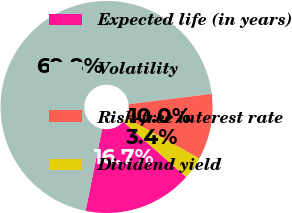Convert chart. <chart><loc_0><loc_0><loc_500><loc_500><pie_chart><fcel>Expected life (in years)<fcel>Volatility<fcel>Risk-free interest rate<fcel>Dividend yield<nl><fcel>16.7%<fcel>69.85%<fcel>10.05%<fcel>3.4%<nl></chart> 